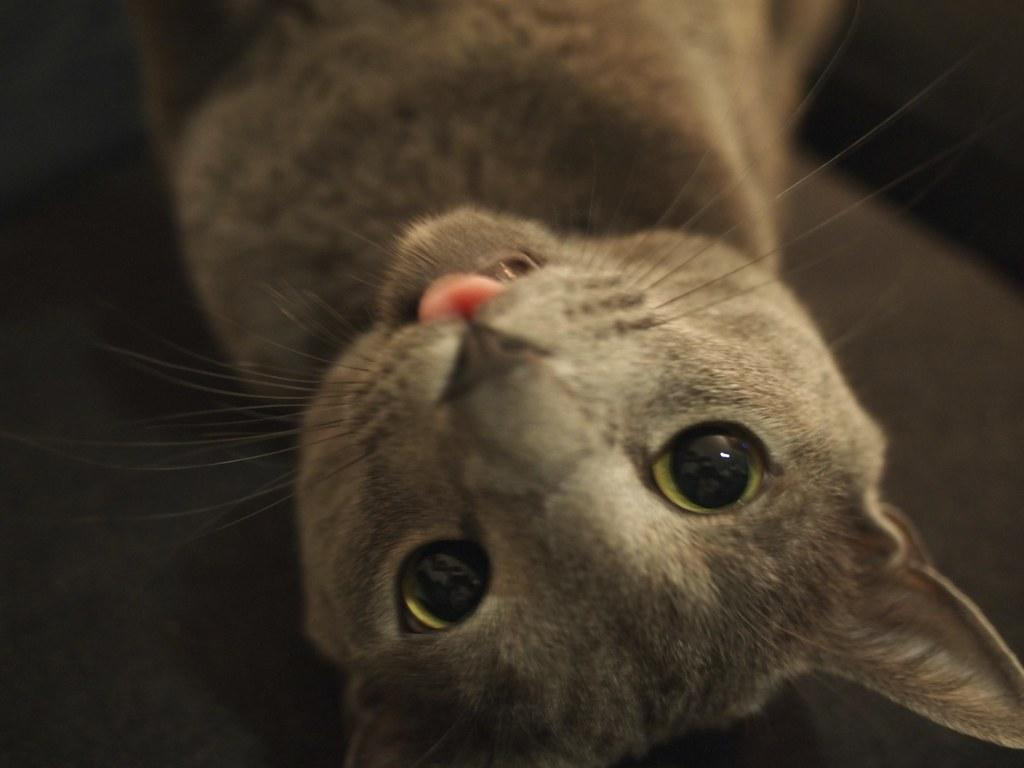What is the main subject of the image? There is a cat in the center of the image. What is the cat doing in the image? The cat appears to be lying on an object. Can you describe the background of the image? There is an object in the background of the image. What type of poison is the cat using to protect itself in the image? There is no poison present in the image; the cat is simply lying on an object. Can you tell me how the grandfather is interacting with the cat in the image? There is no grandfather present in the image; it only features a cat lying on an object. 